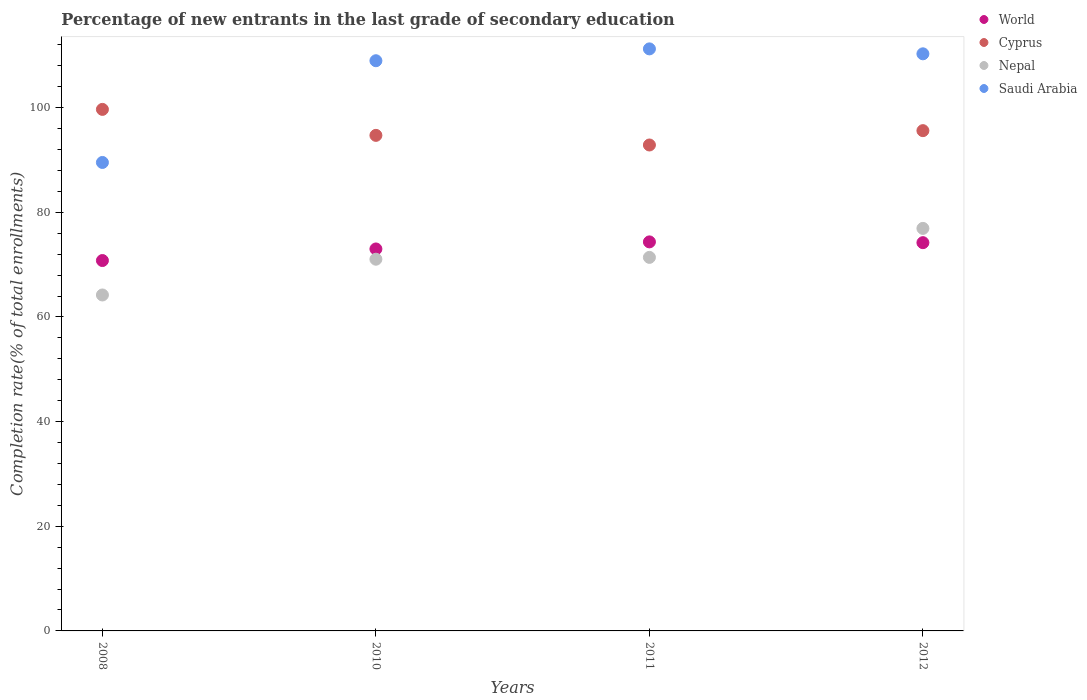Is the number of dotlines equal to the number of legend labels?
Provide a succinct answer. Yes. What is the percentage of new entrants in Cyprus in 2011?
Your response must be concise. 92.87. Across all years, what is the maximum percentage of new entrants in Nepal?
Your answer should be compact. 76.93. Across all years, what is the minimum percentage of new entrants in Saudi Arabia?
Your response must be concise. 89.53. In which year was the percentage of new entrants in Saudi Arabia minimum?
Your answer should be compact. 2008. What is the total percentage of new entrants in Saudi Arabia in the graph?
Give a very brief answer. 420.05. What is the difference between the percentage of new entrants in Nepal in 2011 and that in 2012?
Provide a succinct answer. -5.54. What is the difference between the percentage of new entrants in Nepal in 2012 and the percentage of new entrants in World in 2008?
Provide a succinct answer. 6.14. What is the average percentage of new entrants in Nepal per year?
Your response must be concise. 70.89. In the year 2011, what is the difference between the percentage of new entrants in Nepal and percentage of new entrants in Saudi Arabia?
Keep it short and to the point. -39.85. In how many years, is the percentage of new entrants in World greater than 20 %?
Keep it short and to the point. 4. What is the ratio of the percentage of new entrants in Cyprus in 2008 to that in 2011?
Your answer should be very brief. 1.07. Is the difference between the percentage of new entrants in Nepal in 2008 and 2012 greater than the difference between the percentage of new entrants in Saudi Arabia in 2008 and 2012?
Provide a succinct answer. Yes. What is the difference between the highest and the second highest percentage of new entrants in World?
Make the answer very short. 0.15. What is the difference between the highest and the lowest percentage of new entrants in World?
Your response must be concise. 3.56. Is it the case that in every year, the sum of the percentage of new entrants in Cyprus and percentage of new entrants in World  is greater than the sum of percentage of new entrants in Nepal and percentage of new entrants in Saudi Arabia?
Give a very brief answer. No. Is it the case that in every year, the sum of the percentage of new entrants in World and percentage of new entrants in Nepal  is greater than the percentage of new entrants in Saudi Arabia?
Ensure brevity in your answer.  Yes. Does the percentage of new entrants in Nepal monotonically increase over the years?
Keep it short and to the point. Yes. Is the percentage of new entrants in Saudi Arabia strictly greater than the percentage of new entrants in Cyprus over the years?
Ensure brevity in your answer.  No. How many dotlines are there?
Your answer should be very brief. 4. How many years are there in the graph?
Make the answer very short. 4. What is the difference between two consecutive major ticks on the Y-axis?
Make the answer very short. 20. Does the graph contain any zero values?
Ensure brevity in your answer.  No. Where does the legend appear in the graph?
Make the answer very short. Top right. How many legend labels are there?
Provide a short and direct response. 4. What is the title of the graph?
Offer a terse response. Percentage of new entrants in the last grade of secondary education. What is the label or title of the X-axis?
Offer a very short reply. Years. What is the label or title of the Y-axis?
Provide a short and direct response. Completion rate(% of total enrollments). What is the Completion rate(% of total enrollments) in World in 2008?
Your answer should be very brief. 70.79. What is the Completion rate(% of total enrollments) of Cyprus in 2008?
Your answer should be very brief. 99.68. What is the Completion rate(% of total enrollments) in Nepal in 2008?
Offer a terse response. 64.21. What is the Completion rate(% of total enrollments) of Saudi Arabia in 2008?
Provide a short and direct response. 89.53. What is the Completion rate(% of total enrollments) in World in 2010?
Your answer should be compact. 73. What is the Completion rate(% of total enrollments) of Cyprus in 2010?
Provide a succinct answer. 94.71. What is the Completion rate(% of total enrollments) in Nepal in 2010?
Your answer should be very brief. 71.04. What is the Completion rate(% of total enrollments) in Saudi Arabia in 2010?
Ensure brevity in your answer.  108.98. What is the Completion rate(% of total enrollments) in World in 2011?
Provide a short and direct response. 74.35. What is the Completion rate(% of total enrollments) in Cyprus in 2011?
Offer a terse response. 92.87. What is the Completion rate(% of total enrollments) in Nepal in 2011?
Make the answer very short. 71.39. What is the Completion rate(% of total enrollments) of Saudi Arabia in 2011?
Provide a short and direct response. 111.24. What is the Completion rate(% of total enrollments) in World in 2012?
Give a very brief answer. 74.2. What is the Completion rate(% of total enrollments) in Cyprus in 2012?
Offer a terse response. 95.61. What is the Completion rate(% of total enrollments) of Nepal in 2012?
Offer a terse response. 76.93. What is the Completion rate(% of total enrollments) in Saudi Arabia in 2012?
Provide a succinct answer. 110.3. Across all years, what is the maximum Completion rate(% of total enrollments) in World?
Keep it short and to the point. 74.35. Across all years, what is the maximum Completion rate(% of total enrollments) of Cyprus?
Keep it short and to the point. 99.68. Across all years, what is the maximum Completion rate(% of total enrollments) in Nepal?
Ensure brevity in your answer.  76.93. Across all years, what is the maximum Completion rate(% of total enrollments) of Saudi Arabia?
Your answer should be very brief. 111.24. Across all years, what is the minimum Completion rate(% of total enrollments) in World?
Your answer should be compact. 70.79. Across all years, what is the minimum Completion rate(% of total enrollments) of Cyprus?
Make the answer very short. 92.87. Across all years, what is the minimum Completion rate(% of total enrollments) in Nepal?
Your answer should be compact. 64.21. Across all years, what is the minimum Completion rate(% of total enrollments) in Saudi Arabia?
Make the answer very short. 89.53. What is the total Completion rate(% of total enrollments) of World in the graph?
Keep it short and to the point. 292.35. What is the total Completion rate(% of total enrollments) in Cyprus in the graph?
Offer a very short reply. 382.87. What is the total Completion rate(% of total enrollments) in Nepal in the graph?
Provide a succinct answer. 283.57. What is the total Completion rate(% of total enrollments) in Saudi Arabia in the graph?
Provide a short and direct response. 420.05. What is the difference between the Completion rate(% of total enrollments) in World in 2008 and that in 2010?
Your response must be concise. -2.21. What is the difference between the Completion rate(% of total enrollments) in Cyprus in 2008 and that in 2010?
Give a very brief answer. 4.96. What is the difference between the Completion rate(% of total enrollments) in Nepal in 2008 and that in 2010?
Ensure brevity in your answer.  -6.83. What is the difference between the Completion rate(% of total enrollments) of Saudi Arabia in 2008 and that in 2010?
Offer a terse response. -19.44. What is the difference between the Completion rate(% of total enrollments) of World in 2008 and that in 2011?
Your answer should be very brief. -3.56. What is the difference between the Completion rate(% of total enrollments) in Cyprus in 2008 and that in 2011?
Make the answer very short. 6.8. What is the difference between the Completion rate(% of total enrollments) in Nepal in 2008 and that in 2011?
Give a very brief answer. -7.18. What is the difference between the Completion rate(% of total enrollments) of Saudi Arabia in 2008 and that in 2011?
Your answer should be very brief. -21.71. What is the difference between the Completion rate(% of total enrollments) of World in 2008 and that in 2012?
Provide a short and direct response. -3.42. What is the difference between the Completion rate(% of total enrollments) in Cyprus in 2008 and that in 2012?
Your answer should be compact. 4.06. What is the difference between the Completion rate(% of total enrollments) of Nepal in 2008 and that in 2012?
Your answer should be very brief. -12.72. What is the difference between the Completion rate(% of total enrollments) of Saudi Arabia in 2008 and that in 2012?
Offer a very short reply. -20.77. What is the difference between the Completion rate(% of total enrollments) of World in 2010 and that in 2011?
Provide a short and direct response. -1.35. What is the difference between the Completion rate(% of total enrollments) in Cyprus in 2010 and that in 2011?
Offer a terse response. 1.84. What is the difference between the Completion rate(% of total enrollments) in Nepal in 2010 and that in 2011?
Provide a short and direct response. -0.35. What is the difference between the Completion rate(% of total enrollments) in Saudi Arabia in 2010 and that in 2011?
Provide a succinct answer. -2.27. What is the difference between the Completion rate(% of total enrollments) in World in 2010 and that in 2012?
Your answer should be compact. -1.2. What is the difference between the Completion rate(% of total enrollments) of Cyprus in 2010 and that in 2012?
Offer a terse response. -0.9. What is the difference between the Completion rate(% of total enrollments) of Nepal in 2010 and that in 2012?
Keep it short and to the point. -5.89. What is the difference between the Completion rate(% of total enrollments) of Saudi Arabia in 2010 and that in 2012?
Your answer should be compact. -1.32. What is the difference between the Completion rate(% of total enrollments) in World in 2011 and that in 2012?
Give a very brief answer. 0.15. What is the difference between the Completion rate(% of total enrollments) of Cyprus in 2011 and that in 2012?
Your response must be concise. -2.74. What is the difference between the Completion rate(% of total enrollments) in Nepal in 2011 and that in 2012?
Keep it short and to the point. -5.54. What is the difference between the Completion rate(% of total enrollments) of Saudi Arabia in 2011 and that in 2012?
Offer a terse response. 0.94. What is the difference between the Completion rate(% of total enrollments) in World in 2008 and the Completion rate(% of total enrollments) in Cyprus in 2010?
Provide a succinct answer. -23.92. What is the difference between the Completion rate(% of total enrollments) in World in 2008 and the Completion rate(% of total enrollments) in Nepal in 2010?
Ensure brevity in your answer.  -0.25. What is the difference between the Completion rate(% of total enrollments) in World in 2008 and the Completion rate(% of total enrollments) in Saudi Arabia in 2010?
Your answer should be very brief. -38.19. What is the difference between the Completion rate(% of total enrollments) of Cyprus in 2008 and the Completion rate(% of total enrollments) of Nepal in 2010?
Give a very brief answer. 28.63. What is the difference between the Completion rate(% of total enrollments) in Cyprus in 2008 and the Completion rate(% of total enrollments) in Saudi Arabia in 2010?
Keep it short and to the point. -9.3. What is the difference between the Completion rate(% of total enrollments) of Nepal in 2008 and the Completion rate(% of total enrollments) of Saudi Arabia in 2010?
Offer a very short reply. -44.77. What is the difference between the Completion rate(% of total enrollments) in World in 2008 and the Completion rate(% of total enrollments) in Cyprus in 2011?
Offer a terse response. -22.08. What is the difference between the Completion rate(% of total enrollments) in World in 2008 and the Completion rate(% of total enrollments) in Nepal in 2011?
Provide a short and direct response. -0.6. What is the difference between the Completion rate(% of total enrollments) in World in 2008 and the Completion rate(% of total enrollments) in Saudi Arabia in 2011?
Make the answer very short. -40.45. What is the difference between the Completion rate(% of total enrollments) of Cyprus in 2008 and the Completion rate(% of total enrollments) of Nepal in 2011?
Ensure brevity in your answer.  28.28. What is the difference between the Completion rate(% of total enrollments) of Cyprus in 2008 and the Completion rate(% of total enrollments) of Saudi Arabia in 2011?
Your answer should be compact. -11.57. What is the difference between the Completion rate(% of total enrollments) of Nepal in 2008 and the Completion rate(% of total enrollments) of Saudi Arabia in 2011?
Make the answer very short. -47.03. What is the difference between the Completion rate(% of total enrollments) in World in 2008 and the Completion rate(% of total enrollments) in Cyprus in 2012?
Your answer should be compact. -24.82. What is the difference between the Completion rate(% of total enrollments) of World in 2008 and the Completion rate(% of total enrollments) of Nepal in 2012?
Offer a terse response. -6.14. What is the difference between the Completion rate(% of total enrollments) in World in 2008 and the Completion rate(% of total enrollments) in Saudi Arabia in 2012?
Keep it short and to the point. -39.51. What is the difference between the Completion rate(% of total enrollments) of Cyprus in 2008 and the Completion rate(% of total enrollments) of Nepal in 2012?
Offer a terse response. 22.74. What is the difference between the Completion rate(% of total enrollments) in Cyprus in 2008 and the Completion rate(% of total enrollments) in Saudi Arabia in 2012?
Your response must be concise. -10.62. What is the difference between the Completion rate(% of total enrollments) in Nepal in 2008 and the Completion rate(% of total enrollments) in Saudi Arabia in 2012?
Make the answer very short. -46.09. What is the difference between the Completion rate(% of total enrollments) in World in 2010 and the Completion rate(% of total enrollments) in Cyprus in 2011?
Give a very brief answer. -19.87. What is the difference between the Completion rate(% of total enrollments) of World in 2010 and the Completion rate(% of total enrollments) of Nepal in 2011?
Ensure brevity in your answer.  1.61. What is the difference between the Completion rate(% of total enrollments) of World in 2010 and the Completion rate(% of total enrollments) of Saudi Arabia in 2011?
Provide a succinct answer. -38.24. What is the difference between the Completion rate(% of total enrollments) in Cyprus in 2010 and the Completion rate(% of total enrollments) in Nepal in 2011?
Your response must be concise. 23.32. What is the difference between the Completion rate(% of total enrollments) in Cyprus in 2010 and the Completion rate(% of total enrollments) in Saudi Arabia in 2011?
Provide a succinct answer. -16.53. What is the difference between the Completion rate(% of total enrollments) in Nepal in 2010 and the Completion rate(% of total enrollments) in Saudi Arabia in 2011?
Offer a very short reply. -40.2. What is the difference between the Completion rate(% of total enrollments) of World in 2010 and the Completion rate(% of total enrollments) of Cyprus in 2012?
Offer a very short reply. -22.61. What is the difference between the Completion rate(% of total enrollments) of World in 2010 and the Completion rate(% of total enrollments) of Nepal in 2012?
Your response must be concise. -3.93. What is the difference between the Completion rate(% of total enrollments) of World in 2010 and the Completion rate(% of total enrollments) of Saudi Arabia in 2012?
Your answer should be compact. -37.3. What is the difference between the Completion rate(% of total enrollments) of Cyprus in 2010 and the Completion rate(% of total enrollments) of Nepal in 2012?
Offer a very short reply. 17.78. What is the difference between the Completion rate(% of total enrollments) in Cyprus in 2010 and the Completion rate(% of total enrollments) in Saudi Arabia in 2012?
Your response must be concise. -15.59. What is the difference between the Completion rate(% of total enrollments) of Nepal in 2010 and the Completion rate(% of total enrollments) of Saudi Arabia in 2012?
Make the answer very short. -39.26. What is the difference between the Completion rate(% of total enrollments) in World in 2011 and the Completion rate(% of total enrollments) in Cyprus in 2012?
Your answer should be very brief. -21.26. What is the difference between the Completion rate(% of total enrollments) in World in 2011 and the Completion rate(% of total enrollments) in Nepal in 2012?
Offer a very short reply. -2.58. What is the difference between the Completion rate(% of total enrollments) in World in 2011 and the Completion rate(% of total enrollments) in Saudi Arabia in 2012?
Your answer should be compact. -35.95. What is the difference between the Completion rate(% of total enrollments) of Cyprus in 2011 and the Completion rate(% of total enrollments) of Nepal in 2012?
Make the answer very short. 15.94. What is the difference between the Completion rate(% of total enrollments) of Cyprus in 2011 and the Completion rate(% of total enrollments) of Saudi Arabia in 2012?
Make the answer very short. -17.43. What is the difference between the Completion rate(% of total enrollments) in Nepal in 2011 and the Completion rate(% of total enrollments) in Saudi Arabia in 2012?
Give a very brief answer. -38.91. What is the average Completion rate(% of total enrollments) in World per year?
Offer a very short reply. 73.09. What is the average Completion rate(% of total enrollments) of Cyprus per year?
Ensure brevity in your answer.  95.72. What is the average Completion rate(% of total enrollments) of Nepal per year?
Offer a very short reply. 70.89. What is the average Completion rate(% of total enrollments) of Saudi Arabia per year?
Your response must be concise. 105.01. In the year 2008, what is the difference between the Completion rate(% of total enrollments) in World and Completion rate(% of total enrollments) in Cyprus?
Offer a very short reply. -28.89. In the year 2008, what is the difference between the Completion rate(% of total enrollments) in World and Completion rate(% of total enrollments) in Nepal?
Your answer should be very brief. 6.58. In the year 2008, what is the difference between the Completion rate(% of total enrollments) in World and Completion rate(% of total enrollments) in Saudi Arabia?
Offer a terse response. -18.74. In the year 2008, what is the difference between the Completion rate(% of total enrollments) in Cyprus and Completion rate(% of total enrollments) in Nepal?
Offer a terse response. 35.47. In the year 2008, what is the difference between the Completion rate(% of total enrollments) of Cyprus and Completion rate(% of total enrollments) of Saudi Arabia?
Your answer should be compact. 10.14. In the year 2008, what is the difference between the Completion rate(% of total enrollments) of Nepal and Completion rate(% of total enrollments) of Saudi Arabia?
Provide a succinct answer. -25.33. In the year 2010, what is the difference between the Completion rate(% of total enrollments) of World and Completion rate(% of total enrollments) of Cyprus?
Keep it short and to the point. -21.71. In the year 2010, what is the difference between the Completion rate(% of total enrollments) in World and Completion rate(% of total enrollments) in Nepal?
Offer a very short reply. 1.96. In the year 2010, what is the difference between the Completion rate(% of total enrollments) of World and Completion rate(% of total enrollments) of Saudi Arabia?
Your answer should be compact. -35.97. In the year 2010, what is the difference between the Completion rate(% of total enrollments) of Cyprus and Completion rate(% of total enrollments) of Nepal?
Offer a very short reply. 23.67. In the year 2010, what is the difference between the Completion rate(% of total enrollments) in Cyprus and Completion rate(% of total enrollments) in Saudi Arabia?
Offer a terse response. -14.26. In the year 2010, what is the difference between the Completion rate(% of total enrollments) of Nepal and Completion rate(% of total enrollments) of Saudi Arabia?
Offer a very short reply. -37.94. In the year 2011, what is the difference between the Completion rate(% of total enrollments) of World and Completion rate(% of total enrollments) of Cyprus?
Offer a terse response. -18.52. In the year 2011, what is the difference between the Completion rate(% of total enrollments) in World and Completion rate(% of total enrollments) in Nepal?
Provide a succinct answer. 2.96. In the year 2011, what is the difference between the Completion rate(% of total enrollments) in World and Completion rate(% of total enrollments) in Saudi Arabia?
Offer a terse response. -36.89. In the year 2011, what is the difference between the Completion rate(% of total enrollments) in Cyprus and Completion rate(% of total enrollments) in Nepal?
Offer a terse response. 21.48. In the year 2011, what is the difference between the Completion rate(% of total enrollments) in Cyprus and Completion rate(% of total enrollments) in Saudi Arabia?
Keep it short and to the point. -18.37. In the year 2011, what is the difference between the Completion rate(% of total enrollments) of Nepal and Completion rate(% of total enrollments) of Saudi Arabia?
Your response must be concise. -39.85. In the year 2012, what is the difference between the Completion rate(% of total enrollments) of World and Completion rate(% of total enrollments) of Cyprus?
Ensure brevity in your answer.  -21.41. In the year 2012, what is the difference between the Completion rate(% of total enrollments) of World and Completion rate(% of total enrollments) of Nepal?
Provide a succinct answer. -2.73. In the year 2012, what is the difference between the Completion rate(% of total enrollments) of World and Completion rate(% of total enrollments) of Saudi Arabia?
Provide a short and direct response. -36.09. In the year 2012, what is the difference between the Completion rate(% of total enrollments) of Cyprus and Completion rate(% of total enrollments) of Nepal?
Offer a terse response. 18.68. In the year 2012, what is the difference between the Completion rate(% of total enrollments) of Cyprus and Completion rate(% of total enrollments) of Saudi Arabia?
Your response must be concise. -14.69. In the year 2012, what is the difference between the Completion rate(% of total enrollments) of Nepal and Completion rate(% of total enrollments) of Saudi Arabia?
Your answer should be very brief. -33.37. What is the ratio of the Completion rate(% of total enrollments) in World in 2008 to that in 2010?
Provide a succinct answer. 0.97. What is the ratio of the Completion rate(% of total enrollments) in Cyprus in 2008 to that in 2010?
Provide a succinct answer. 1.05. What is the ratio of the Completion rate(% of total enrollments) in Nepal in 2008 to that in 2010?
Give a very brief answer. 0.9. What is the ratio of the Completion rate(% of total enrollments) of Saudi Arabia in 2008 to that in 2010?
Your answer should be compact. 0.82. What is the ratio of the Completion rate(% of total enrollments) in World in 2008 to that in 2011?
Make the answer very short. 0.95. What is the ratio of the Completion rate(% of total enrollments) in Cyprus in 2008 to that in 2011?
Give a very brief answer. 1.07. What is the ratio of the Completion rate(% of total enrollments) in Nepal in 2008 to that in 2011?
Ensure brevity in your answer.  0.9. What is the ratio of the Completion rate(% of total enrollments) in Saudi Arabia in 2008 to that in 2011?
Make the answer very short. 0.8. What is the ratio of the Completion rate(% of total enrollments) of World in 2008 to that in 2012?
Keep it short and to the point. 0.95. What is the ratio of the Completion rate(% of total enrollments) of Cyprus in 2008 to that in 2012?
Make the answer very short. 1.04. What is the ratio of the Completion rate(% of total enrollments) in Nepal in 2008 to that in 2012?
Offer a very short reply. 0.83. What is the ratio of the Completion rate(% of total enrollments) of Saudi Arabia in 2008 to that in 2012?
Provide a short and direct response. 0.81. What is the ratio of the Completion rate(% of total enrollments) in World in 2010 to that in 2011?
Ensure brevity in your answer.  0.98. What is the ratio of the Completion rate(% of total enrollments) of Cyprus in 2010 to that in 2011?
Keep it short and to the point. 1.02. What is the ratio of the Completion rate(% of total enrollments) of Saudi Arabia in 2010 to that in 2011?
Ensure brevity in your answer.  0.98. What is the ratio of the Completion rate(% of total enrollments) of World in 2010 to that in 2012?
Your answer should be very brief. 0.98. What is the ratio of the Completion rate(% of total enrollments) in Cyprus in 2010 to that in 2012?
Give a very brief answer. 0.99. What is the ratio of the Completion rate(% of total enrollments) of Nepal in 2010 to that in 2012?
Ensure brevity in your answer.  0.92. What is the ratio of the Completion rate(% of total enrollments) in Saudi Arabia in 2010 to that in 2012?
Your answer should be compact. 0.99. What is the ratio of the Completion rate(% of total enrollments) of Cyprus in 2011 to that in 2012?
Keep it short and to the point. 0.97. What is the ratio of the Completion rate(% of total enrollments) in Nepal in 2011 to that in 2012?
Your response must be concise. 0.93. What is the ratio of the Completion rate(% of total enrollments) in Saudi Arabia in 2011 to that in 2012?
Your answer should be compact. 1.01. What is the difference between the highest and the second highest Completion rate(% of total enrollments) in World?
Provide a succinct answer. 0.15. What is the difference between the highest and the second highest Completion rate(% of total enrollments) in Cyprus?
Keep it short and to the point. 4.06. What is the difference between the highest and the second highest Completion rate(% of total enrollments) in Nepal?
Give a very brief answer. 5.54. What is the difference between the highest and the second highest Completion rate(% of total enrollments) of Saudi Arabia?
Ensure brevity in your answer.  0.94. What is the difference between the highest and the lowest Completion rate(% of total enrollments) in World?
Provide a succinct answer. 3.56. What is the difference between the highest and the lowest Completion rate(% of total enrollments) in Cyprus?
Your answer should be compact. 6.8. What is the difference between the highest and the lowest Completion rate(% of total enrollments) in Nepal?
Keep it short and to the point. 12.72. What is the difference between the highest and the lowest Completion rate(% of total enrollments) in Saudi Arabia?
Give a very brief answer. 21.71. 